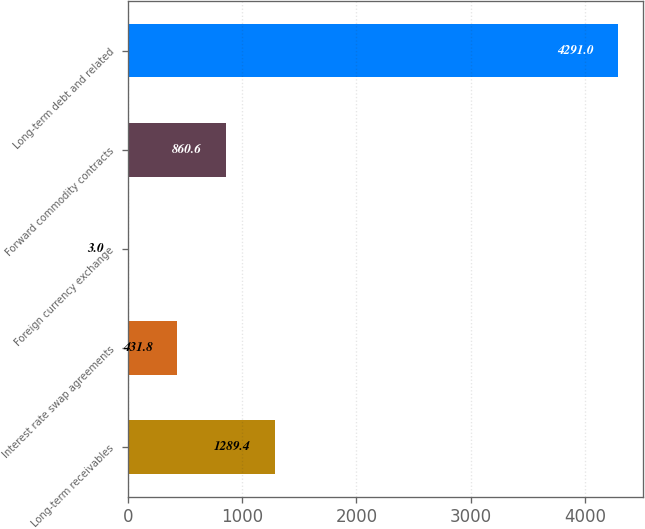Convert chart. <chart><loc_0><loc_0><loc_500><loc_500><bar_chart><fcel>Long-term receivables<fcel>Interest rate swap agreements<fcel>Foreign currency exchange<fcel>Forward commodity contracts<fcel>Long-term debt and related<nl><fcel>1289.4<fcel>431.8<fcel>3<fcel>860.6<fcel>4291<nl></chart> 